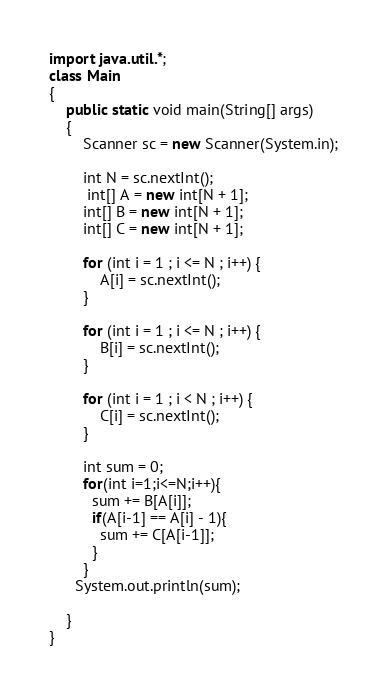<code> <loc_0><loc_0><loc_500><loc_500><_Java_>
import java.util.*;
class Main
{
    public static void main(String[] args)
    {
        Scanner sc = new Scanner(System.in);
     	
      	int N = sc.nextInt();
      	 int[] A = new int[N + 1];
        int[] B = new int[N + 1];
        int[] C = new int[N + 1];
 
        for (int i = 1 ; i <= N ; i++) {
            A[i] = sc.nextInt();
        }
 
        for (int i = 1 ; i <= N ; i++) {
            B[i] = sc.nextInt();
        }
 
        for (int i = 1 ; i < N ; i++) {
            C[i] = sc.nextInt();
        }
 
      	int sum = 0;
      	for(int i=1;i<=N;i++){
          sum += B[A[i]];
          if(A[i-1] == A[i] - 1){
          	sum += C[A[i-1]];
          }
        } 
      System.out.println(sum);
      	
    }       
}</code> 